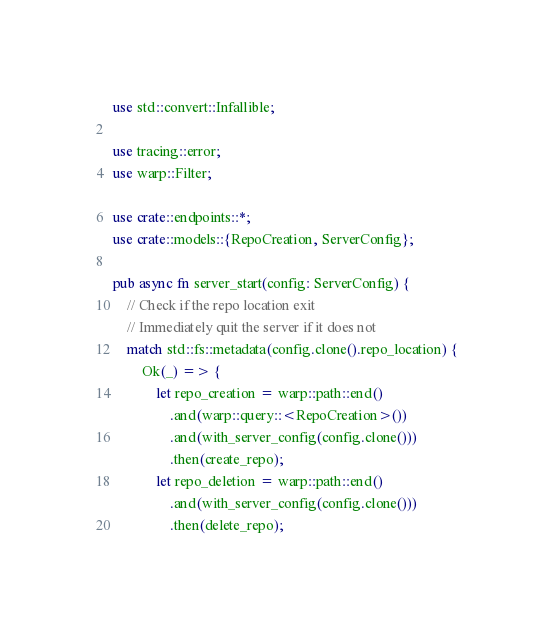Convert code to text. <code><loc_0><loc_0><loc_500><loc_500><_Rust_>use std::convert::Infallible;

use tracing::error;
use warp::Filter;

use crate::endpoints::*;
use crate::models::{RepoCreation, ServerConfig};

pub async fn server_start(config: ServerConfig) {
    // Check if the repo location exit
    // Immediately quit the server if it does not
    match std::fs::metadata(config.clone().repo_location) {
        Ok(_) => {
            let repo_creation = warp::path::end()
                .and(warp::query::<RepoCreation>())
                .and(with_server_config(config.clone()))
                .then(create_repo);
            let repo_deletion = warp::path::end()
                .and(with_server_config(config.clone()))
                .then(delete_repo);
</code> 